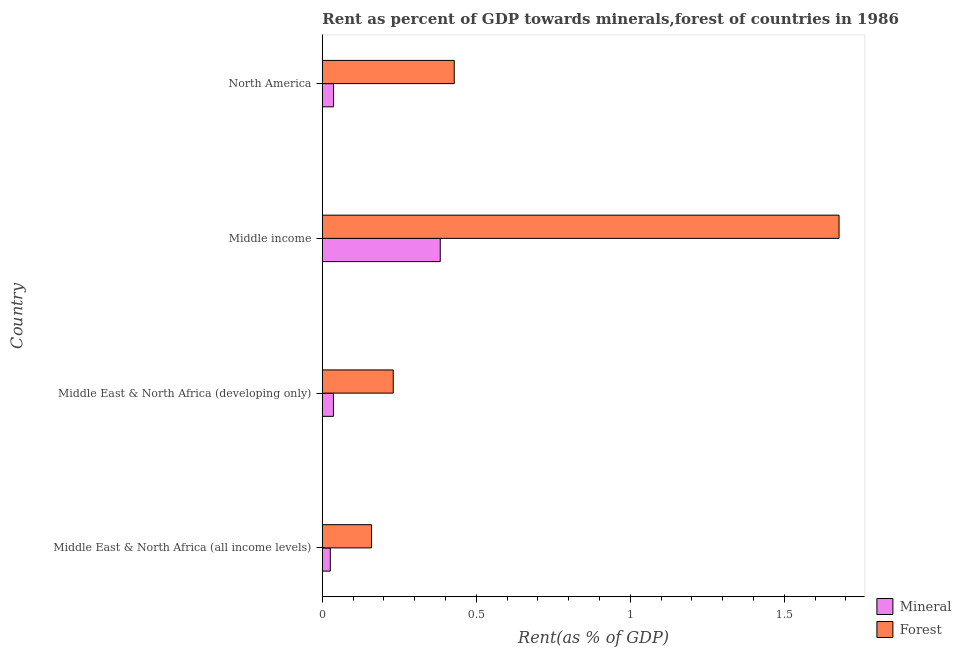How many groups of bars are there?
Make the answer very short. 4. How many bars are there on the 4th tick from the top?
Offer a very short reply. 2. In how many cases, is the number of bars for a given country not equal to the number of legend labels?
Your answer should be very brief. 0. What is the mineral rent in Middle income?
Your response must be concise. 0.38. Across all countries, what is the maximum forest rent?
Provide a short and direct response. 1.68. Across all countries, what is the minimum forest rent?
Provide a short and direct response. 0.16. In which country was the forest rent maximum?
Provide a succinct answer. Middle income. In which country was the forest rent minimum?
Give a very brief answer. Middle East & North Africa (all income levels). What is the total forest rent in the graph?
Keep it short and to the point. 2.5. What is the difference between the mineral rent in Middle East & North Africa (developing only) and that in Middle income?
Ensure brevity in your answer.  -0.35. What is the difference between the forest rent in Middle East & North Africa (all income levels) and the mineral rent in Middle East & North Africa (developing only)?
Your answer should be very brief. 0.12. What is the average forest rent per country?
Give a very brief answer. 0.62. What is the difference between the forest rent and mineral rent in Middle East & North Africa (developing only)?
Ensure brevity in your answer.  0.19. What is the ratio of the mineral rent in Middle East & North Africa (developing only) to that in North America?
Your answer should be very brief. 0.99. Is the mineral rent in Middle East & North Africa (all income levels) less than that in North America?
Ensure brevity in your answer.  Yes. Is the difference between the forest rent in Middle income and North America greater than the difference between the mineral rent in Middle income and North America?
Give a very brief answer. Yes. What is the difference between the highest and the second highest mineral rent?
Provide a succinct answer. 0.35. What is the difference between the highest and the lowest mineral rent?
Offer a very short reply. 0.36. In how many countries, is the mineral rent greater than the average mineral rent taken over all countries?
Your answer should be very brief. 1. Is the sum of the forest rent in Middle income and North America greater than the maximum mineral rent across all countries?
Ensure brevity in your answer.  Yes. What does the 2nd bar from the top in Middle income represents?
Provide a succinct answer. Mineral. What does the 1st bar from the bottom in Middle East & North Africa (all income levels) represents?
Your answer should be compact. Mineral. Are all the bars in the graph horizontal?
Make the answer very short. Yes. Does the graph contain grids?
Offer a terse response. No. How are the legend labels stacked?
Offer a very short reply. Vertical. What is the title of the graph?
Give a very brief answer. Rent as percent of GDP towards minerals,forest of countries in 1986. Does "Savings" appear as one of the legend labels in the graph?
Ensure brevity in your answer.  No. What is the label or title of the X-axis?
Your response must be concise. Rent(as % of GDP). What is the label or title of the Y-axis?
Your answer should be very brief. Country. What is the Rent(as % of GDP) of Mineral in Middle East & North Africa (all income levels)?
Your answer should be compact. 0.03. What is the Rent(as % of GDP) of Forest in Middle East & North Africa (all income levels)?
Give a very brief answer. 0.16. What is the Rent(as % of GDP) of Mineral in Middle East & North Africa (developing only)?
Ensure brevity in your answer.  0.04. What is the Rent(as % of GDP) of Forest in Middle East & North Africa (developing only)?
Offer a very short reply. 0.23. What is the Rent(as % of GDP) of Mineral in Middle income?
Give a very brief answer. 0.38. What is the Rent(as % of GDP) of Forest in Middle income?
Keep it short and to the point. 1.68. What is the Rent(as % of GDP) of Mineral in North America?
Provide a short and direct response. 0.04. What is the Rent(as % of GDP) of Forest in North America?
Your answer should be compact. 0.43. Across all countries, what is the maximum Rent(as % of GDP) in Mineral?
Ensure brevity in your answer.  0.38. Across all countries, what is the maximum Rent(as % of GDP) of Forest?
Keep it short and to the point. 1.68. Across all countries, what is the minimum Rent(as % of GDP) of Mineral?
Your response must be concise. 0.03. Across all countries, what is the minimum Rent(as % of GDP) in Forest?
Make the answer very short. 0.16. What is the total Rent(as % of GDP) in Mineral in the graph?
Provide a succinct answer. 0.48. What is the total Rent(as % of GDP) of Forest in the graph?
Offer a terse response. 2.5. What is the difference between the Rent(as % of GDP) of Mineral in Middle East & North Africa (all income levels) and that in Middle East & North Africa (developing only)?
Provide a short and direct response. -0.01. What is the difference between the Rent(as % of GDP) of Forest in Middle East & North Africa (all income levels) and that in Middle East & North Africa (developing only)?
Give a very brief answer. -0.07. What is the difference between the Rent(as % of GDP) of Mineral in Middle East & North Africa (all income levels) and that in Middle income?
Provide a succinct answer. -0.36. What is the difference between the Rent(as % of GDP) in Forest in Middle East & North Africa (all income levels) and that in Middle income?
Make the answer very short. -1.52. What is the difference between the Rent(as % of GDP) in Mineral in Middle East & North Africa (all income levels) and that in North America?
Offer a terse response. -0.01. What is the difference between the Rent(as % of GDP) in Forest in Middle East & North Africa (all income levels) and that in North America?
Provide a short and direct response. -0.27. What is the difference between the Rent(as % of GDP) of Mineral in Middle East & North Africa (developing only) and that in Middle income?
Your answer should be compact. -0.35. What is the difference between the Rent(as % of GDP) of Forest in Middle East & North Africa (developing only) and that in Middle income?
Provide a short and direct response. -1.45. What is the difference between the Rent(as % of GDP) of Mineral in Middle East & North Africa (developing only) and that in North America?
Offer a terse response. -0. What is the difference between the Rent(as % of GDP) in Forest in Middle East & North Africa (developing only) and that in North America?
Offer a terse response. -0.2. What is the difference between the Rent(as % of GDP) of Mineral in Middle income and that in North America?
Ensure brevity in your answer.  0.35. What is the difference between the Rent(as % of GDP) of Forest in Middle income and that in North America?
Your answer should be compact. 1.25. What is the difference between the Rent(as % of GDP) in Mineral in Middle East & North Africa (all income levels) and the Rent(as % of GDP) in Forest in Middle East & North Africa (developing only)?
Offer a terse response. -0.2. What is the difference between the Rent(as % of GDP) of Mineral in Middle East & North Africa (all income levels) and the Rent(as % of GDP) of Forest in Middle income?
Ensure brevity in your answer.  -1.65. What is the difference between the Rent(as % of GDP) in Mineral in Middle East & North Africa (all income levels) and the Rent(as % of GDP) in Forest in North America?
Provide a succinct answer. -0.4. What is the difference between the Rent(as % of GDP) of Mineral in Middle East & North Africa (developing only) and the Rent(as % of GDP) of Forest in Middle income?
Make the answer very short. -1.64. What is the difference between the Rent(as % of GDP) in Mineral in Middle East & North Africa (developing only) and the Rent(as % of GDP) in Forest in North America?
Offer a terse response. -0.39. What is the difference between the Rent(as % of GDP) of Mineral in Middle income and the Rent(as % of GDP) of Forest in North America?
Ensure brevity in your answer.  -0.05. What is the average Rent(as % of GDP) in Mineral per country?
Offer a very short reply. 0.12. What is the average Rent(as % of GDP) of Forest per country?
Provide a short and direct response. 0.62. What is the difference between the Rent(as % of GDP) in Mineral and Rent(as % of GDP) in Forest in Middle East & North Africa (all income levels)?
Give a very brief answer. -0.13. What is the difference between the Rent(as % of GDP) in Mineral and Rent(as % of GDP) in Forest in Middle East & North Africa (developing only)?
Offer a very short reply. -0.19. What is the difference between the Rent(as % of GDP) of Mineral and Rent(as % of GDP) of Forest in Middle income?
Give a very brief answer. -1.29. What is the difference between the Rent(as % of GDP) in Mineral and Rent(as % of GDP) in Forest in North America?
Provide a short and direct response. -0.39. What is the ratio of the Rent(as % of GDP) in Mineral in Middle East & North Africa (all income levels) to that in Middle East & North Africa (developing only)?
Offer a very short reply. 0.72. What is the ratio of the Rent(as % of GDP) in Forest in Middle East & North Africa (all income levels) to that in Middle East & North Africa (developing only)?
Keep it short and to the point. 0.69. What is the ratio of the Rent(as % of GDP) in Mineral in Middle East & North Africa (all income levels) to that in Middle income?
Your answer should be compact. 0.07. What is the ratio of the Rent(as % of GDP) of Forest in Middle East & North Africa (all income levels) to that in Middle income?
Keep it short and to the point. 0.1. What is the ratio of the Rent(as % of GDP) in Mineral in Middle East & North Africa (all income levels) to that in North America?
Offer a terse response. 0.71. What is the ratio of the Rent(as % of GDP) of Forest in Middle East & North Africa (all income levels) to that in North America?
Keep it short and to the point. 0.37. What is the ratio of the Rent(as % of GDP) in Mineral in Middle East & North Africa (developing only) to that in Middle income?
Provide a succinct answer. 0.09. What is the ratio of the Rent(as % of GDP) of Forest in Middle East & North Africa (developing only) to that in Middle income?
Ensure brevity in your answer.  0.14. What is the ratio of the Rent(as % of GDP) in Forest in Middle East & North Africa (developing only) to that in North America?
Ensure brevity in your answer.  0.54. What is the ratio of the Rent(as % of GDP) of Mineral in Middle income to that in North America?
Keep it short and to the point. 10.5. What is the ratio of the Rent(as % of GDP) in Forest in Middle income to that in North America?
Provide a succinct answer. 3.92. What is the difference between the highest and the second highest Rent(as % of GDP) in Mineral?
Your response must be concise. 0.35. What is the difference between the highest and the second highest Rent(as % of GDP) of Forest?
Offer a terse response. 1.25. What is the difference between the highest and the lowest Rent(as % of GDP) of Mineral?
Make the answer very short. 0.36. What is the difference between the highest and the lowest Rent(as % of GDP) in Forest?
Provide a succinct answer. 1.52. 